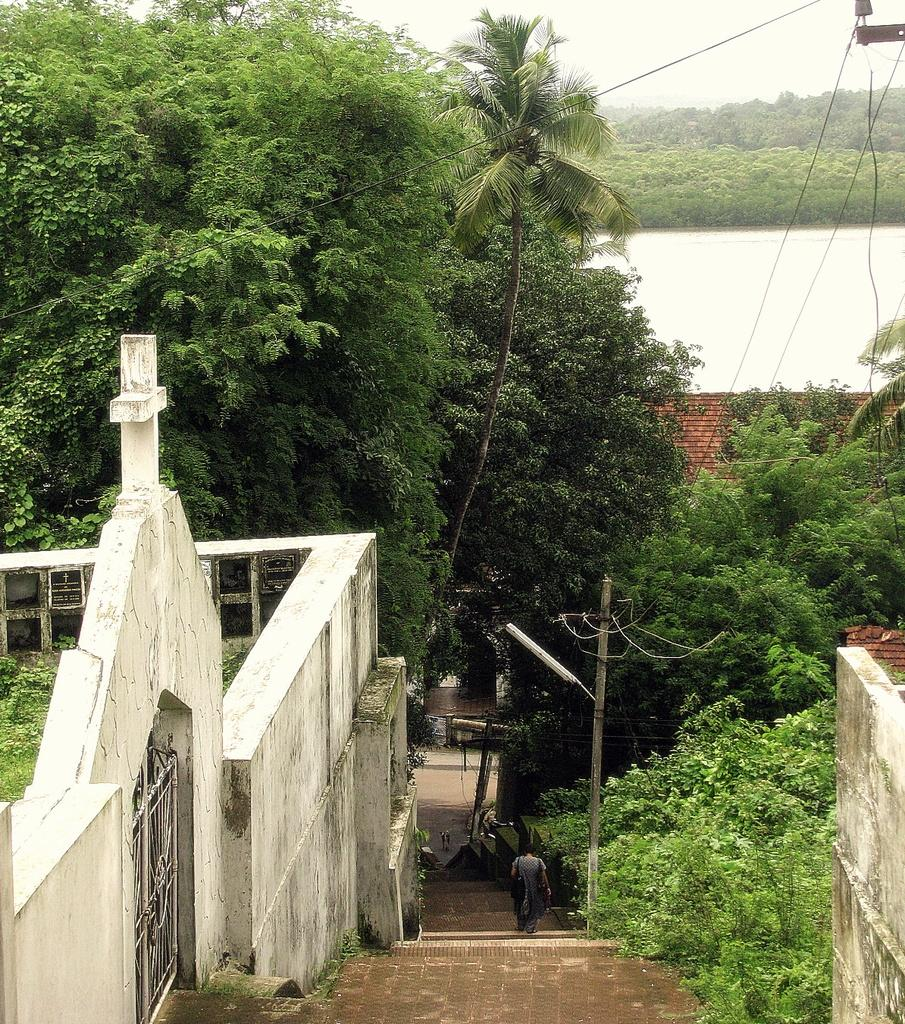What type of natural elements can be seen in the image? There are trees in the image. What type of man-made structures can be seen in the image? There are buildings in the image. What type of water feature is visible in the image? There is water visible in the image. What type of utility infrastructure can be seen in the image? There are wires in the image. What part of the natural environment is visible in the background of the image? The sky is visible in the background of the image. What architectural feature can be seen in the background of the image? There are stairs in the background of the image. Are there any people present in the image? Yes, there is a person in the image. What type of bean is being used as a prop in the image? There is no bean present in the image. What color are the eyes of the person in the image? The provided facts do not mention the person's eyes, so we cannot determine their color from the image. 